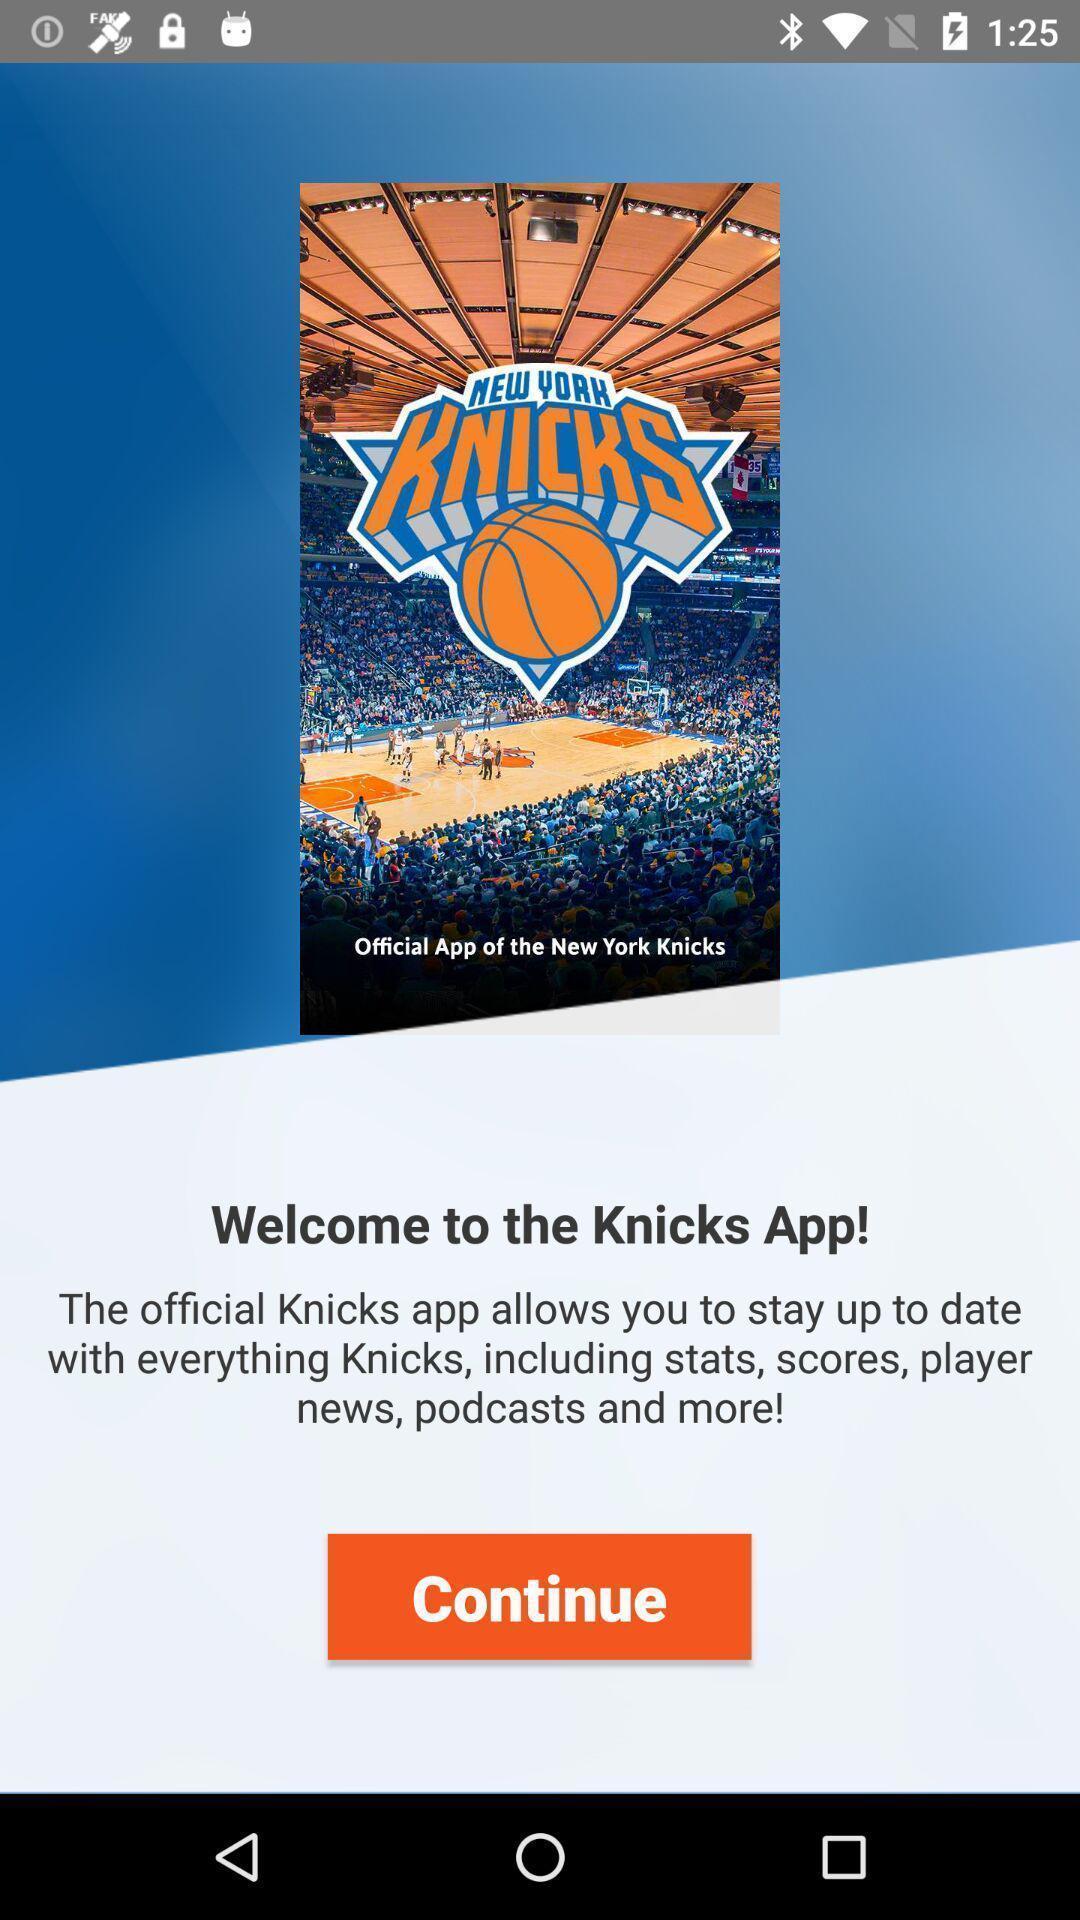Summarize the main components in this picture. Welcome page. 